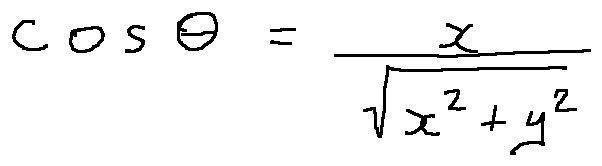<formula> <loc_0><loc_0><loc_500><loc_500>\cos \theta = \frac { x } { \sqrt { x ^ { 2 } + y ^ { 2 } } }</formula> 